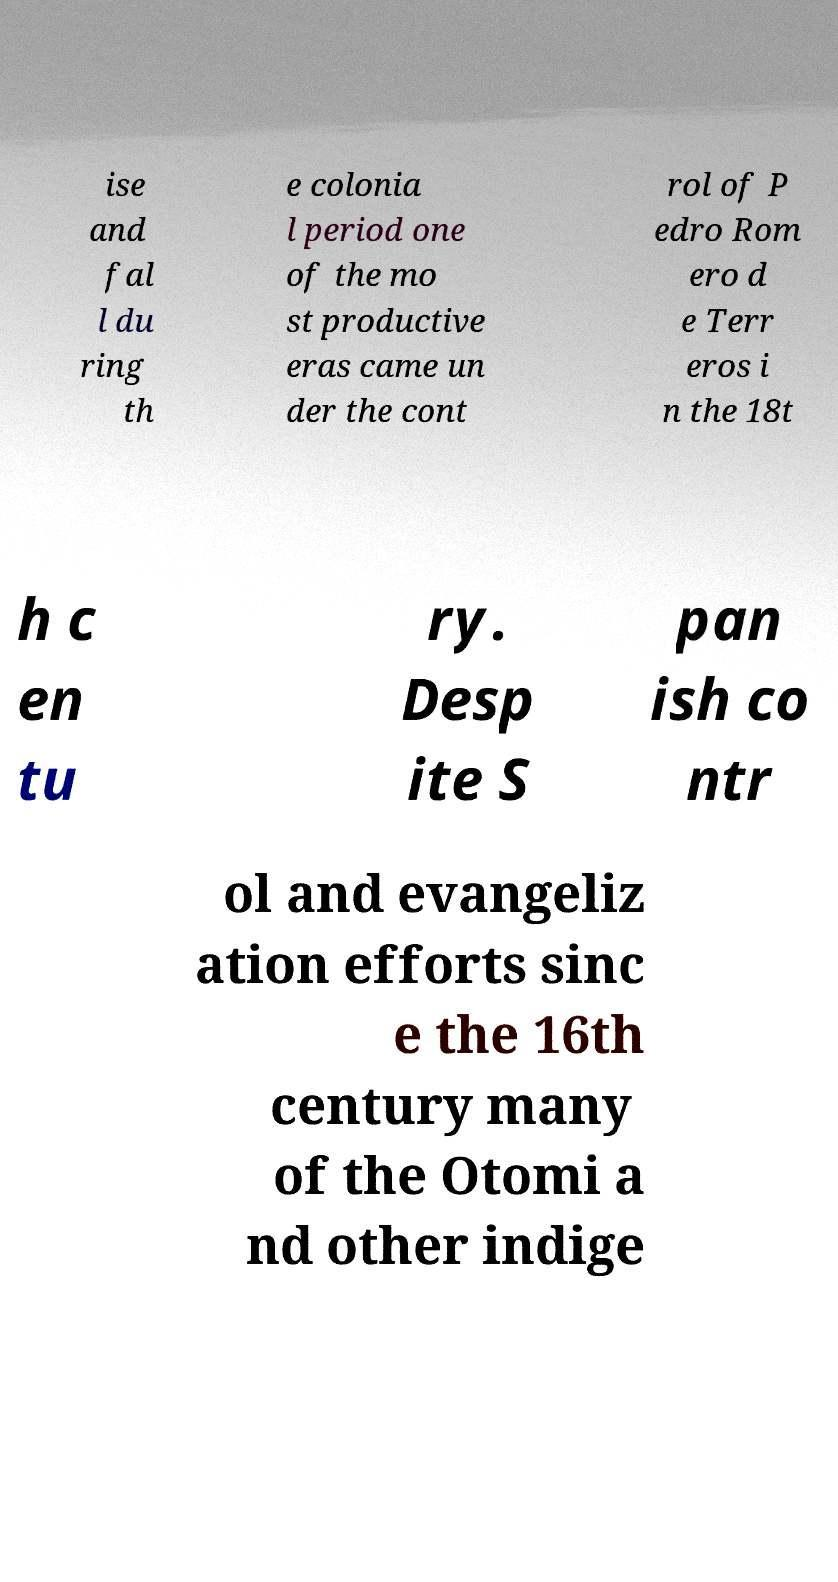I need the written content from this picture converted into text. Can you do that? ise and fal l du ring th e colonia l period one of the mo st productive eras came un der the cont rol of P edro Rom ero d e Terr eros i n the 18t h c en tu ry. Desp ite S pan ish co ntr ol and evangeliz ation efforts sinc e the 16th century many of the Otomi a nd other indige 